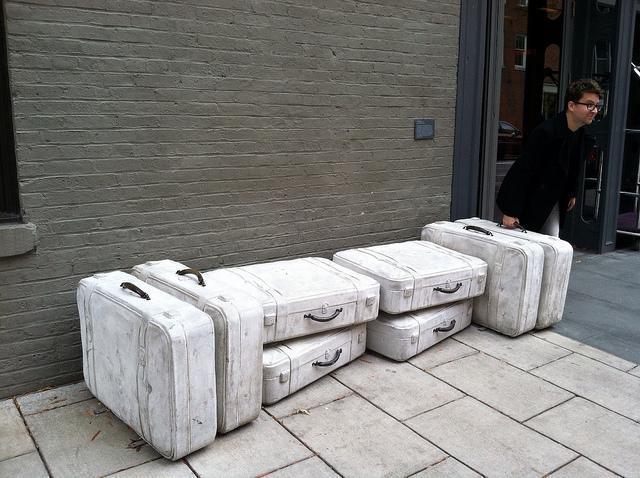How many cases are there?
Give a very brief answer. 8. How many pieces of luggage are white?
Give a very brief answer. 8. How many suitcases are green?
Give a very brief answer. 0. How many luggages are seen?
Give a very brief answer. 8. How many suitcases can you see?
Give a very brief answer. 8. How many tall sheep are there?
Give a very brief answer. 0. 